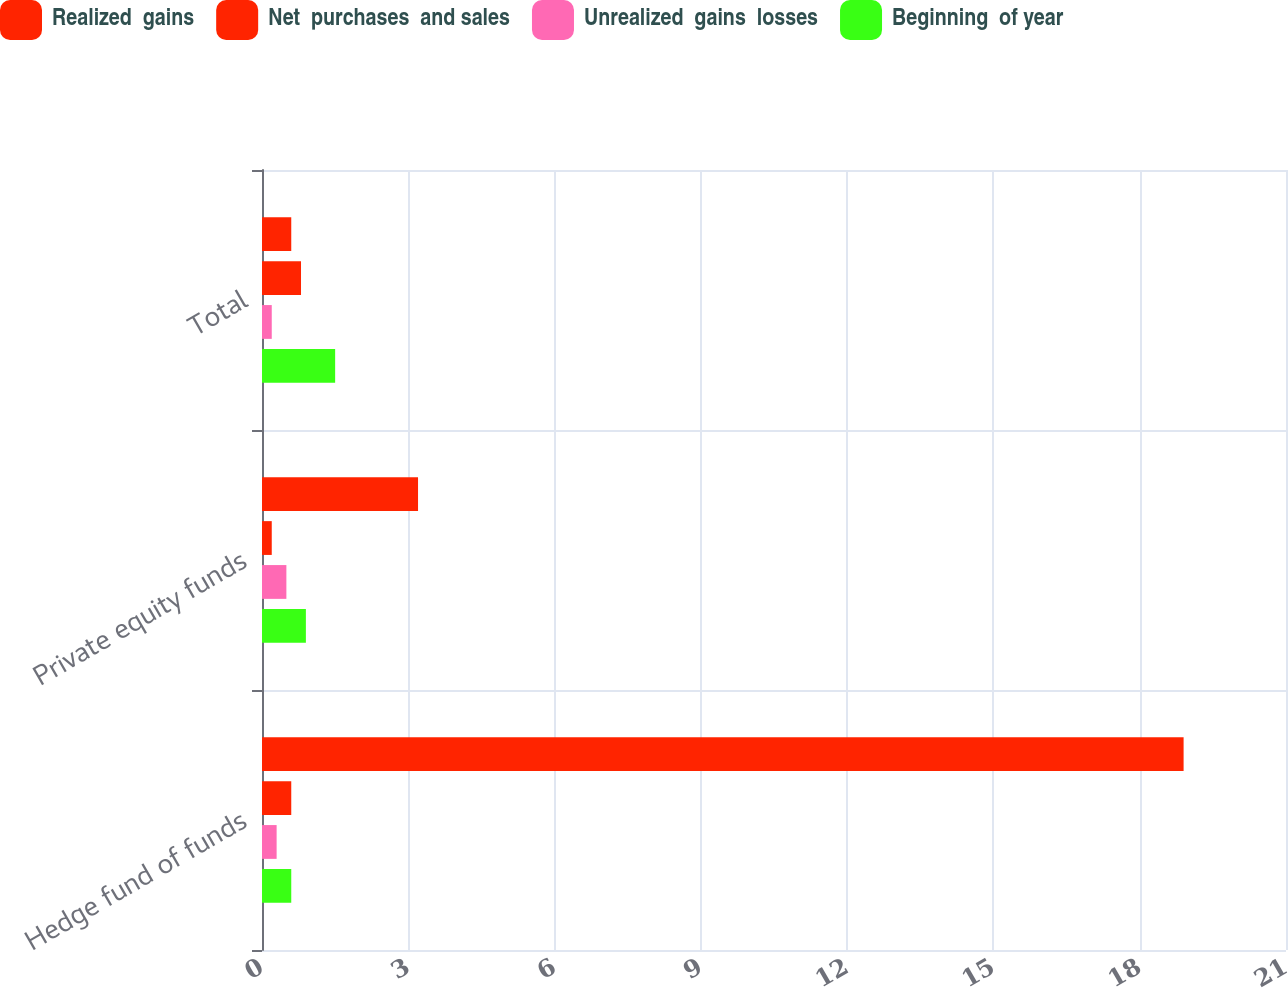Convert chart. <chart><loc_0><loc_0><loc_500><loc_500><stacked_bar_chart><ecel><fcel>Hedge fund of funds<fcel>Private equity funds<fcel>Total<nl><fcel>Realized  gains<fcel>18.9<fcel>3.2<fcel>0.6<nl><fcel>Net  purchases  and sales<fcel>0.6<fcel>0.2<fcel>0.8<nl><fcel>Unrealized  gains  losses<fcel>0.3<fcel>0.5<fcel>0.2<nl><fcel>Beginning  of year<fcel>0.6<fcel>0.9<fcel>1.5<nl></chart> 